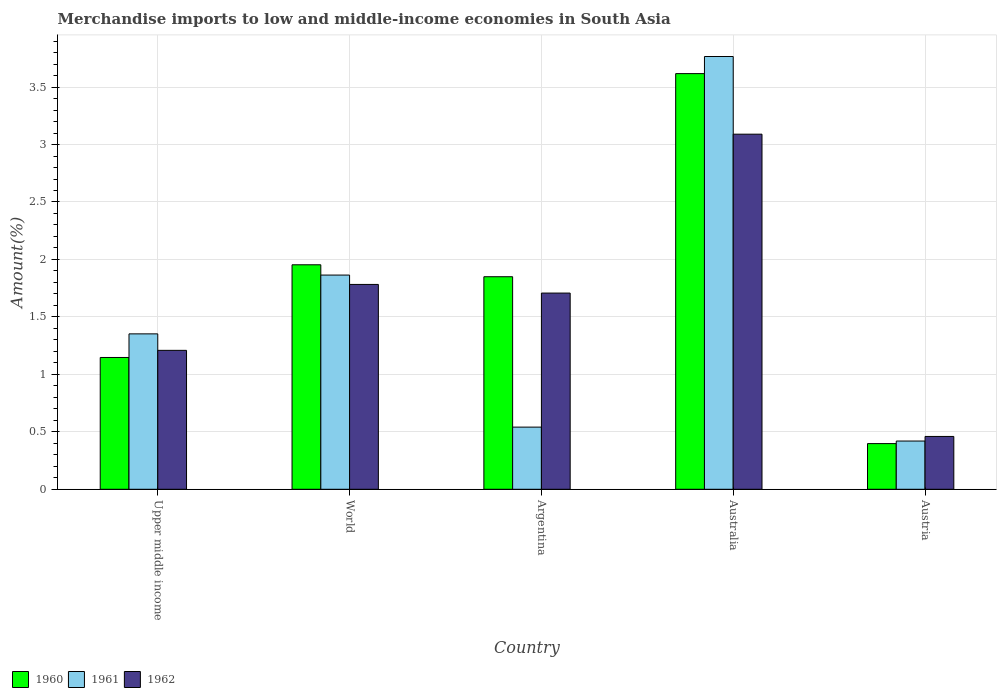How many groups of bars are there?
Your response must be concise. 5. Are the number of bars per tick equal to the number of legend labels?
Make the answer very short. Yes. Are the number of bars on each tick of the X-axis equal?
Your answer should be very brief. Yes. How many bars are there on the 5th tick from the left?
Your answer should be compact. 3. How many bars are there on the 2nd tick from the right?
Your answer should be compact. 3. What is the label of the 1st group of bars from the left?
Provide a short and direct response. Upper middle income. What is the percentage of amount earned from merchandise imports in 1960 in Upper middle income?
Give a very brief answer. 1.15. Across all countries, what is the maximum percentage of amount earned from merchandise imports in 1961?
Your answer should be very brief. 3.77. Across all countries, what is the minimum percentage of amount earned from merchandise imports in 1961?
Your answer should be compact. 0.42. In which country was the percentage of amount earned from merchandise imports in 1962 maximum?
Ensure brevity in your answer.  Australia. What is the total percentage of amount earned from merchandise imports in 1960 in the graph?
Give a very brief answer. 8.96. What is the difference between the percentage of amount earned from merchandise imports in 1960 in Australia and that in Upper middle income?
Give a very brief answer. 2.47. What is the difference between the percentage of amount earned from merchandise imports in 1960 in Australia and the percentage of amount earned from merchandise imports in 1962 in Argentina?
Keep it short and to the point. 1.91. What is the average percentage of amount earned from merchandise imports in 1962 per country?
Ensure brevity in your answer.  1.65. What is the difference between the percentage of amount earned from merchandise imports of/in 1962 and percentage of amount earned from merchandise imports of/in 1961 in Upper middle income?
Offer a terse response. -0.14. In how many countries, is the percentage of amount earned from merchandise imports in 1960 greater than 3 %?
Your response must be concise. 1. What is the ratio of the percentage of amount earned from merchandise imports in 1961 in Argentina to that in Upper middle income?
Your answer should be compact. 0.4. Is the difference between the percentage of amount earned from merchandise imports in 1962 in Australia and Upper middle income greater than the difference between the percentage of amount earned from merchandise imports in 1961 in Australia and Upper middle income?
Your answer should be compact. No. What is the difference between the highest and the second highest percentage of amount earned from merchandise imports in 1962?
Give a very brief answer. -1.31. What is the difference between the highest and the lowest percentage of amount earned from merchandise imports in 1960?
Your answer should be very brief. 3.22. What does the 1st bar from the left in Argentina represents?
Keep it short and to the point. 1960. Is it the case that in every country, the sum of the percentage of amount earned from merchandise imports in 1961 and percentage of amount earned from merchandise imports in 1962 is greater than the percentage of amount earned from merchandise imports in 1960?
Ensure brevity in your answer.  Yes. How many bars are there?
Provide a succinct answer. 15. What is the difference between two consecutive major ticks on the Y-axis?
Your response must be concise. 0.5. How are the legend labels stacked?
Make the answer very short. Horizontal. What is the title of the graph?
Ensure brevity in your answer.  Merchandise imports to low and middle-income economies in South Asia. What is the label or title of the X-axis?
Give a very brief answer. Country. What is the label or title of the Y-axis?
Offer a terse response. Amount(%). What is the Amount(%) of 1960 in Upper middle income?
Your response must be concise. 1.15. What is the Amount(%) in 1961 in Upper middle income?
Your response must be concise. 1.35. What is the Amount(%) of 1962 in Upper middle income?
Provide a short and direct response. 1.21. What is the Amount(%) of 1960 in World?
Your response must be concise. 1.95. What is the Amount(%) in 1961 in World?
Make the answer very short. 1.86. What is the Amount(%) in 1962 in World?
Make the answer very short. 1.78. What is the Amount(%) of 1960 in Argentina?
Ensure brevity in your answer.  1.85. What is the Amount(%) in 1961 in Argentina?
Offer a terse response. 0.54. What is the Amount(%) in 1962 in Argentina?
Make the answer very short. 1.71. What is the Amount(%) in 1960 in Australia?
Ensure brevity in your answer.  3.62. What is the Amount(%) of 1961 in Australia?
Offer a terse response. 3.77. What is the Amount(%) in 1962 in Australia?
Provide a short and direct response. 3.09. What is the Amount(%) of 1960 in Austria?
Make the answer very short. 0.4. What is the Amount(%) in 1961 in Austria?
Your answer should be compact. 0.42. What is the Amount(%) in 1962 in Austria?
Offer a very short reply. 0.46. Across all countries, what is the maximum Amount(%) in 1960?
Your response must be concise. 3.62. Across all countries, what is the maximum Amount(%) of 1961?
Make the answer very short. 3.77. Across all countries, what is the maximum Amount(%) of 1962?
Give a very brief answer. 3.09. Across all countries, what is the minimum Amount(%) in 1960?
Offer a very short reply. 0.4. Across all countries, what is the minimum Amount(%) of 1961?
Your answer should be compact. 0.42. Across all countries, what is the minimum Amount(%) of 1962?
Your response must be concise. 0.46. What is the total Amount(%) in 1960 in the graph?
Give a very brief answer. 8.96. What is the total Amount(%) of 1961 in the graph?
Your response must be concise. 7.94. What is the total Amount(%) in 1962 in the graph?
Your answer should be compact. 8.25. What is the difference between the Amount(%) of 1960 in Upper middle income and that in World?
Offer a very short reply. -0.81. What is the difference between the Amount(%) of 1961 in Upper middle income and that in World?
Offer a terse response. -0.51. What is the difference between the Amount(%) of 1962 in Upper middle income and that in World?
Your answer should be very brief. -0.57. What is the difference between the Amount(%) in 1960 in Upper middle income and that in Argentina?
Offer a very short reply. -0.7. What is the difference between the Amount(%) of 1961 in Upper middle income and that in Argentina?
Ensure brevity in your answer.  0.81. What is the difference between the Amount(%) in 1962 in Upper middle income and that in Argentina?
Your response must be concise. -0.5. What is the difference between the Amount(%) in 1960 in Upper middle income and that in Australia?
Your answer should be compact. -2.47. What is the difference between the Amount(%) in 1961 in Upper middle income and that in Australia?
Make the answer very short. -2.41. What is the difference between the Amount(%) of 1962 in Upper middle income and that in Australia?
Give a very brief answer. -1.88. What is the difference between the Amount(%) of 1960 in Upper middle income and that in Austria?
Ensure brevity in your answer.  0.75. What is the difference between the Amount(%) of 1961 in Upper middle income and that in Austria?
Keep it short and to the point. 0.93. What is the difference between the Amount(%) in 1962 in Upper middle income and that in Austria?
Offer a very short reply. 0.75. What is the difference between the Amount(%) of 1960 in World and that in Argentina?
Provide a succinct answer. 0.1. What is the difference between the Amount(%) in 1961 in World and that in Argentina?
Give a very brief answer. 1.32. What is the difference between the Amount(%) of 1962 in World and that in Argentina?
Keep it short and to the point. 0.08. What is the difference between the Amount(%) in 1960 in World and that in Australia?
Make the answer very short. -1.66. What is the difference between the Amount(%) in 1961 in World and that in Australia?
Provide a short and direct response. -1.9. What is the difference between the Amount(%) of 1962 in World and that in Australia?
Offer a terse response. -1.31. What is the difference between the Amount(%) of 1960 in World and that in Austria?
Offer a terse response. 1.56. What is the difference between the Amount(%) in 1961 in World and that in Austria?
Your answer should be compact. 1.44. What is the difference between the Amount(%) of 1962 in World and that in Austria?
Provide a short and direct response. 1.32. What is the difference between the Amount(%) of 1960 in Argentina and that in Australia?
Ensure brevity in your answer.  -1.77. What is the difference between the Amount(%) of 1961 in Argentina and that in Australia?
Provide a short and direct response. -3.23. What is the difference between the Amount(%) of 1962 in Argentina and that in Australia?
Ensure brevity in your answer.  -1.38. What is the difference between the Amount(%) of 1960 in Argentina and that in Austria?
Provide a succinct answer. 1.45. What is the difference between the Amount(%) in 1961 in Argentina and that in Austria?
Offer a terse response. 0.12. What is the difference between the Amount(%) in 1962 in Argentina and that in Austria?
Your response must be concise. 1.25. What is the difference between the Amount(%) in 1960 in Australia and that in Austria?
Offer a terse response. 3.22. What is the difference between the Amount(%) of 1961 in Australia and that in Austria?
Your response must be concise. 3.35. What is the difference between the Amount(%) of 1962 in Australia and that in Austria?
Give a very brief answer. 2.63. What is the difference between the Amount(%) in 1960 in Upper middle income and the Amount(%) in 1961 in World?
Your answer should be very brief. -0.72. What is the difference between the Amount(%) in 1960 in Upper middle income and the Amount(%) in 1962 in World?
Make the answer very short. -0.64. What is the difference between the Amount(%) in 1961 in Upper middle income and the Amount(%) in 1962 in World?
Your answer should be very brief. -0.43. What is the difference between the Amount(%) in 1960 in Upper middle income and the Amount(%) in 1961 in Argentina?
Your answer should be compact. 0.61. What is the difference between the Amount(%) in 1960 in Upper middle income and the Amount(%) in 1962 in Argentina?
Your answer should be compact. -0.56. What is the difference between the Amount(%) of 1961 in Upper middle income and the Amount(%) of 1962 in Argentina?
Your answer should be very brief. -0.35. What is the difference between the Amount(%) of 1960 in Upper middle income and the Amount(%) of 1961 in Australia?
Give a very brief answer. -2.62. What is the difference between the Amount(%) of 1960 in Upper middle income and the Amount(%) of 1962 in Australia?
Provide a short and direct response. -1.94. What is the difference between the Amount(%) in 1961 in Upper middle income and the Amount(%) in 1962 in Australia?
Ensure brevity in your answer.  -1.74. What is the difference between the Amount(%) in 1960 in Upper middle income and the Amount(%) in 1961 in Austria?
Offer a very short reply. 0.73. What is the difference between the Amount(%) of 1960 in Upper middle income and the Amount(%) of 1962 in Austria?
Provide a succinct answer. 0.69. What is the difference between the Amount(%) of 1961 in Upper middle income and the Amount(%) of 1962 in Austria?
Offer a very short reply. 0.89. What is the difference between the Amount(%) in 1960 in World and the Amount(%) in 1961 in Argentina?
Make the answer very short. 1.41. What is the difference between the Amount(%) in 1960 in World and the Amount(%) in 1962 in Argentina?
Offer a terse response. 0.25. What is the difference between the Amount(%) of 1961 in World and the Amount(%) of 1962 in Argentina?
Your answer should be compact. 0.16. What is the difference between the Amount(%) of 1960 in World and the Amount(%) of 1961 in Australia?
Make the answer very short. -1.81. What is the difference between the Amount(%) in 1960 in World and the Amount(%) in 1962 in Australia?
Your response must be concise. -1.14. What is the difference between the Amount(%) of 1961 in World and the Amount(%) of 1962 in Australia?
Your answer should be very brief. -1.23. What is the difference between the Amount(%) of 1960 in World and the Amount(%) of 1961 in Austria?
Make the answer very short. 1.53. What is the difference between the Amount(%) in 1960 in World and the Amount(%) in 1962 in Austria?
Provide a succinct answer. 1.49. What is the difference between the Amount(%) of 1961 in World and the Amount(%) of 1962 in Austria?
Offer a terse response. 1.4. What is the difference between the Amount(%) of 1960 in Argentina and the Amount(%) of 1961 in Australia?
Make the answer very short. -1.92. What is the difference between the Amount(%) of 1960 in Argentina and the Amount(%) of 1962 in Australia?
Make the answer very short. -1.24. What is the difference between the Amount(%) in 1961 in Argentina and the Amount(%) in 1962 in Australia?
Give a very brief answer. -2.55. What is the difference between the Amount(%) in 1960 in Argentina and the Amount(%) in 1961 in Austria?
Provide a short and direct response. 1.43. What is the difference between the Amount(%) of 1960 in Argentina and the Amount(%) of 1962 in Austria?
Make the answer very short. 1.39. What is the difference between the Amount(%) in 1961 in Argentina and the Amount(%) in 1962 in Austria?
Make the answer very short. 0.08. What is the difference between the Amount(%) in 1960 in Australia and the Amount(%) in 1961 in Austria?
Provide a succinct answer. 3.2. What is the difference between the Amount(%) in 1960 in Australia and the Amount(%) in 1962 in Austria?
Offer a very short reply. 3.16. What is the difference between the Amount(%) in 1961 in Australia and the Amount(%) in 1962 in Austria?
Your response must be concise. 3.31. What is the average Amount(%) in 1960 per country?
Your answer should be very brief. 1.79. What is the average Amount(%) in 1961 per country?
Keep it short and to the point. 1.59. What is the average Amount(%) in 1962 per country?
Provide a succinct answer. 1.65. What is the difference between the Amount(%) of 1960 and Amount(%) of 1961 in Upper middle income?
Keep it short and to the point. -0.21. What is the difference between the Amount(%) in 1960 and Amount(%) in 1962 in Upper middle income?
Provide a succinct answer. -0.06. What is the difference between the Amount(%) of 1961 and Amount(%) of 1962 in Upper middle income?
Your answer should be compact. 0.14. What is the difference between the Amount(%) of 1960 and Amount(%) of 1961 in World?
Give a very brief answer. 0.09. What is the difference between the Amount(%) in 1960 and Amount(%) in 1962 in World?
Keep it short and to the point. 0.17. What is the difference between the Amount(%) in 1961 and Amount(%) in 1962 in World?
Your response must be concise. 0.08. What is the difference between the Amount(%) in 1960 and Amount(%) in 1961 in Argentina?
Make the answer very short. 1.31. What is the difference between the Amount(%) of 1960 and Amount(%) of 1962 in Argentina?
Offer a very short reply. 0.14. What is the difference between the Amount(%) of 1961 and Amount(%) of 1962 in Argentina?
Keep it short and to the point. -1.17. What is the difference between the Amount(%) in 1960 and Amount(%) in 1961 in Australia?
Keep it short and to the point. -0.15. What is the difference between the Amount(%) in 1960 and Amount(%) in 1962 in Australia?
Provide a succinct answer. 0.53. What is the difference between the Amount(%) of 1961 and Amount(%) of 1962 in Australia?
Your answer should be very brief. 0.68. What is the difference between the Amount(%) of 1960 and Amount(%) of 1961 in Austria?
Give a very brief answer. -0.02. What is the difference between the Amount(%) of 1960 and Amount(%) of 1962 in Austria?
Keep it short and to the point. -0.06. What is the difference between the Amount(%) in 1961 and Amount(%) in 1962 in Austria?
Keep it short and to the point. -0.04. What is the ratio of the Amount(%) of 1960 in Upper middle income to that in World?
Your response must be concise. 0.59. What is the ratio of the Amount(%) in 1961 in Upper middle income to that in World?
Provide a succinct answer. 0.73. What is the ratio of the Amount(%) of 1962 in Upper middle income to that in World?
Provide a succinct answer. 0.68. What is the ratio of the Amount(%) in 1960 in Upper middle income to that in Argentina?
Give a very brief answer. 0.62. What is the ratio of the Amount(%) of 1961 in Upper middle income to that in Argentina?
Provide a succinct answer. 2.5. What is the ratio of the Amount(%) of 1962 in Upper middle income to that in Argentina?
Your response must be concise. 0.71. What is the ratio of the Amount(%) of 1960 in Upper middle income to that in Australia?
Provide a succinct answer. 0.32. What is the ratio of the Amount(%) in 1961 in Upper middle income to that in Australia?
Your answer should be very brief. 0.36. What is the ratio of the Amount(%) of 1962 in Upper middle income to that in Australia?
Offer a very short reply. 0.39. What is the ratio of the Amount(%) of 1960 in Upper middle income to that in Austria?
Provide a short and direct response. 2.89. What is the ratio of the Amount(%) of 1961 in Upper middle income to that in Austria?
Offer a very short reply. 3.22. What is the ratio of the Amount(%) in 1962 in Upper middle income to that in Austria?
Your answer should be very brief. 2.63. What is the ratio of the Amount(%) in 1960 in World to that in Argentina?
Keep it short and to the point. 1.06. What is the ratio of the Amount(%) of 1961 in World to that in Argentina?
Ensure brevity in your answer.  3.45. What is the ratio of the Amount(%) of 1962 in World to that in Argentina?
Offer a terse response. 1.04. What is the ratio of the Amount(%) of 1960 in World to that in Australia?
Ensure brevity in your answer.  0.54. What is the ratio of the Amount(%) of 1961 in World to that in Australia?
Provide a succinct answer. 0.49. What is the ratio of the Amount(%) of 1962 in World to that in Australia?
Give a very brief answer. 0.58. What is the ratio of the Amount(%) of 1960 in World to that in Austria?
Offer a terse response. 4.91. What is the ratio of the Amount(%) in 1961 in World to that in Austria?
Ensure brevity in your answer.  4.44. What is the ratio of the Amount(%) of 1962 in World to that in Austria?
Ensure brevity in your answer.  3.88. What is the ratio of the Amount(%) in 1960 in Argentina to that in Australia?
Make the answer very short. 0.51. What is the ratio of the Amount(%) of 1961 in Argentina to that in Australia?
Your answer should be very brief. 0.14. What is the ratio of the Amount(%) in 1962 in Argentina to that in Australia?
Your answer should be compact. 0.55. What is the ratio of the Amount(%) of 1960 in Argentina to that in Austria?
Make the answer very short. 4.65. What is the ratio of the Amount(%) of 1961 in Argentina to that in Austria?
Offer a very short reply. 1.29. What is the ratio of the Amount(%) in 1962 in Argentina to that in Austria?
Provide a succinct answer. 3.71. What is the ratio of the Amount(%) of 1960 in Australia to that in Austria?
Provide a short and direct response. 9.1. What is the ratio of the Amount(%) of 1961 in Australia to that in Austria?
Your answer should be very brief. 8.97. What is the ratio of the Amount(%) of 1962 in Australia to that in Austria?
Offer a terse response. 6.72. What is the difference between the highest and the second highest Amount(%) of 1960?
Offer a very short reply. 1.66. What is the difference between the highest and the second highest Amount(%) in 1961?
Give a very brief answer. 1.9. What is the difference between the highest and the second highest Amount(%) of 1962?
Provide a short and direct response. 1.31. What is the difference between the highest and the lowest Amount(%) of 1960?
Your answer should be very brief. 3.22. What is the difference between the highest and the lowest Amount(%) of 1961?
Offer a very short reply. 3.35. What is the difference between the highest and the lowest Amount(%) in 1962?
Your answer should be very brief. 2.63. 